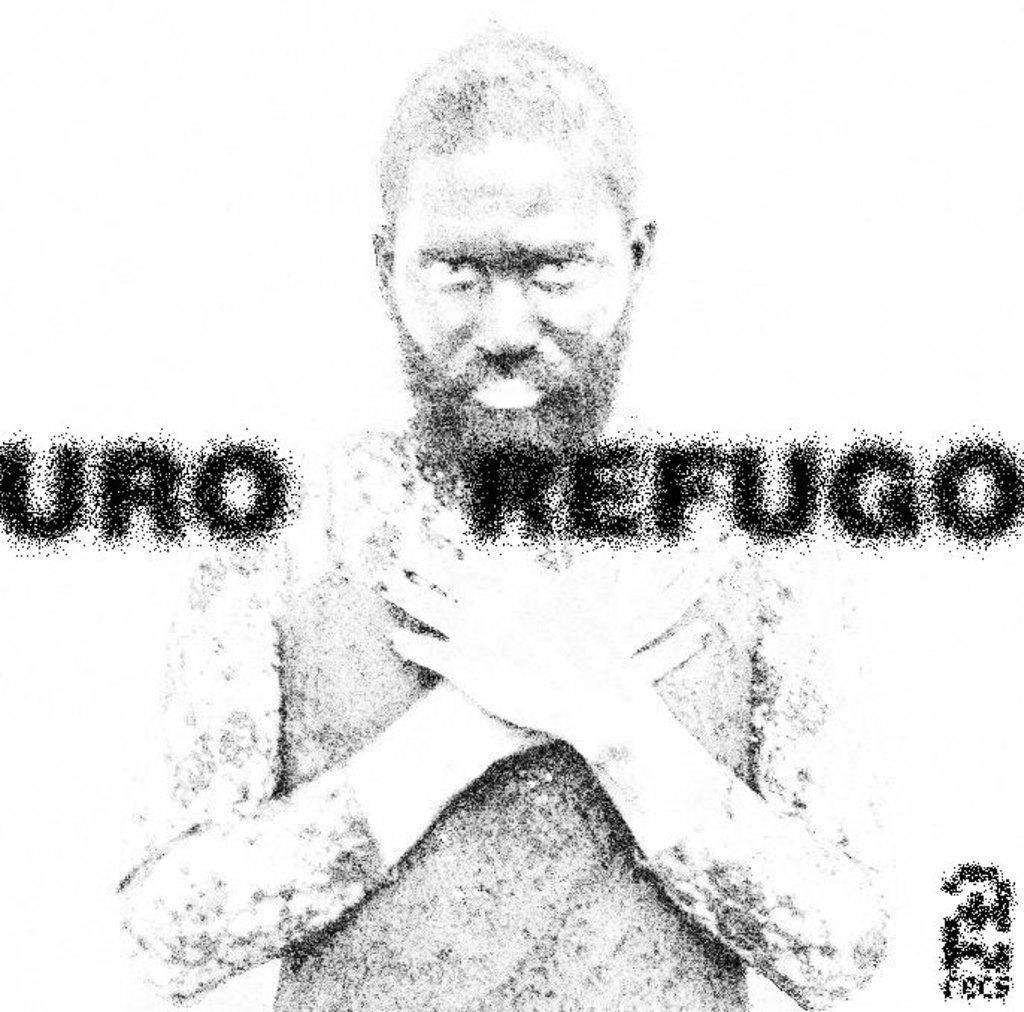Please provide a concise description of this image. In this picture we can observe a sketch of a person. We can observe some text on this picture. The background is in white color. 